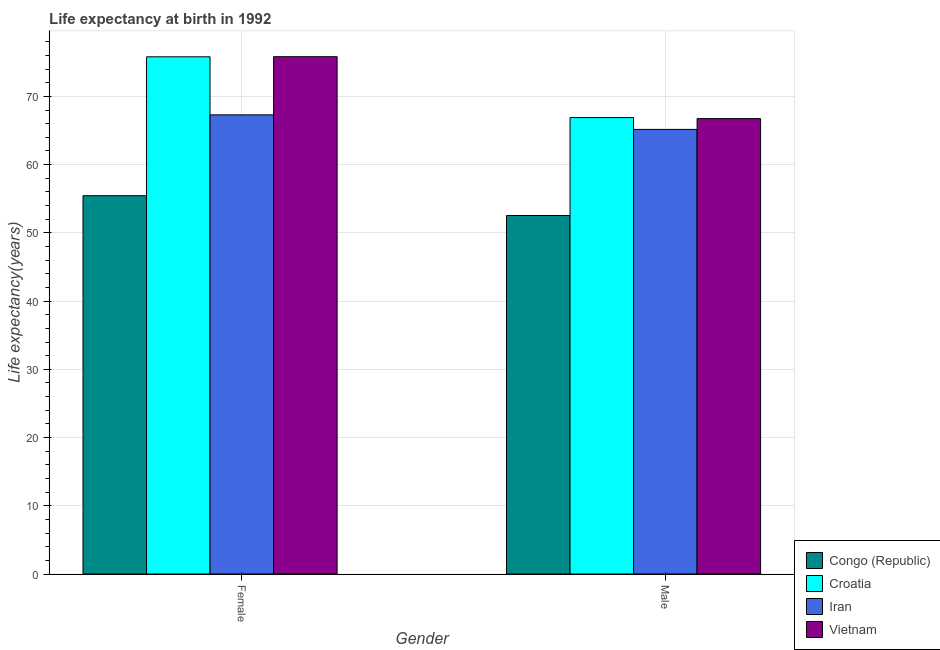How many groups of bars are there?
Make the answer very short. 2. What is the label of the 2nd group of bars from the left?
Make the answer very short. Male. What is the life expectancy(male) in Iran?
Provide a short and direct response. 65.16. Across all countries, what is the maximum life expectancy(male)?
Ensure brevity in your answer.  66.9. Across all countries, what is the minimum life expectancy(female)?
Provide a succinct answer. 55.45. In which country was the life expectancy(male) maximum?
Your response must be concise. Croatia. In which country was the life expectancy(female) minimum?
Your response must be concise. Congo (Republic). What is the total life expectancy(female) in the graph?
Your answer should be very brief. 274.36. What is the difference between the life expectancy(female) in Iran and that in Croatia?
Your response must be concise. -8.5. What is the difference between the life expectancy(male) in Iran and the life expectancy(female) in Croatia?
Your answer should be very brief. -10.64. What is the average life expectancy(female) per country?
Offer a terse response. 68.59. What is the difference between the life expectancy(female) and life expectancy(male) in Congo (Republic)?
Offer a very short reply. 2.9. What is the ratio of the life expectancy(female) in Iran to that in Vietnam?
Provide a succinct answer. 0.89. In how many countries, is the life expectancy(male) greater than the average life expectancy(male) taken over all countries?
Give a very brief answer. 3. What does the 4th bar from the left in Female represents?
Offer a terse response. Vietnam. What does the 1st bar from the right in Female represents?
Offer a terse response. Vietnam. How many countries are there in the graph?
Keep it short and to the point. 4. Does the graph contain grids?
Make the answer very short. Yes. How many legend labels are there?
Your answer should be compact. 4. How are the legend labels stacked?
Your answer should be compact. Vertical. What is the title of the graph?
Ensure brevity in your answer.  Life expectancy at birth in 1992. Does "Macao" appear as one of the legend labels in the graph?
Make the answer very short. No. What is the label or title of the Y-axis?
Your answer should be compact. Life expectancy(years). What is the Life expectancy(years) of Congo (Republic) in Female?
Provide a short and direct response. 55.45. What is the Life expectancy(years) of Croatia in Female?
Ensure brevity in your answer.  75.8. What is the Life expectancy(years) of Iran in Female?
Make the answer very short. 67.3. What is the Life expectancy(years) in Vietnam in Female?
Give a very brief answer. 75.82. What is the Life expectancy(years) of Congo (Republic) in Male?
Your response must be concise. 52.54. What is the Life expectancy(years) of Croatia in Male?
Give a very brief answer. 66.9. What is the Life expectancy(years) in Iran in Male?
Give a very brief answer. 65.16. What is the Life expectancy(years) in Vietnam in Male?
Provide a short and direct response. 66.74. Across all Gender, what is the maximum Life expectancy(years) in Congo (Republic)?
Offer a terse response. 55.45. Across all Gender, what is the maximum Life expectancy(years) in Croatia?
Keep it short and to the point. 75.8. Across all Gender, what is the maximum Life expectancy(years) of Iran?
Your answer should be compact. 67.3. Across all Gender, what is the maximum Life expectancy(years) of Vietnam?
Your response must be concise. 75.82. Across all Gender, what is the minimum Life expectancy(years) of Congo (Republic)?
Your response must be concise. 52.54. Across all Gender, what is the minimum Life expectancy(years) of Croatia?
Provide a succinct answer. 66.9. Across all Gender, what is the minimum Life expectancy(years) in Iran?
Keep it short and to the point. 65.16. Across all Gender, what is the minimum Life expectancy(years) of Vietnam?
Provide a succinct answer. 66.74. What is the total Life expectancy(years) of Congo (Republic) in the graph?
Offer a very short reply. 107.99. What is the total Life expectancy(years) of Croatia in the graph?
Keep it short and to the point. 142.7. What is the total Life expectancy(years) of Iran in the graph?
Offer a terse response. 132.46. What is the total Life expectancy(years) in Vietnam in the graph?
Offer a terse response. 142.56. What is the difference between the Life expectancy(years) in Congo (Republic) in Female and that in Male?
Offer a terse response. 2.9. What is the difference between the Life expectancy(years) of Croatia in Female and that in Male?
Your answer should be very brief. 8.9. What is the difference between the Life expectancy(years) in Iran in Female and that in Male?
Provide a short and direct response. 2.13. What is the difference between the Life expectancy(years) of Vietnam in Female and that in Male?
Your response must be concise. 9.08. What is the difference between the Life expectancy(years) of Congo (Republic) in Female and the Life expectancy(years) of Croatia in Male?
Offer a terse response. -11.46. What is the difference between the Life expectancy(years) of Congo (Republic) in Female and the Life expectancy(years) of Iran in Male?
Make the answer very short. -9.72. What is the difference between the Life expectancy(years) in Congo (Republic) in Female and the Life expectancy(years) in Vietnam in Male?
Your answer should be compact. -11.3. What is the difference between the Life expectancy(years) in Croatia in Female and the Life expectancy(years) in Iran in Male?
Your response must be concise. 10.64. What is the difference between the Life expectancy(years) of Croatia in Female and the Life expectancy(years) of Vietnam in Male?
Your response must be concise. 9.06. What is the difference between the Life expectancy(years) in Iran in Female and the Life expectancy(years) in Vietnam in Male?
Make the answer very short. 0.55. What is the average Life expectancy(years) of Congo (Republic) per Gender?
Provide a succinct answer. 53.99. What is the average Life expectancy(years) in Croatia per Gender?
Ensure brevity in your answer.  71.35. What is the average Life expectancy(years) of Iran per Gender?
Your answer should be compact. 66.23. What is the average Life expectancy(years) in Vietnam per Gender?
Your answer should be compact. 71.28. What is the difference between the Life expectancy(years) of Congo (Republic) and Life expectancy(years) of Croatia in Female?
Provide a succinct answer. -20.36. What is the difference between the Life expectancy(years) of Congo (Republic) and Life expectancy(years) of Iran in Female?
Keep it short and to the point. -11.85. What is the difference between the Life expectancy(years) of Congo (Republic) and Life expectancy(years) of Vietnam in Female?
Your answer should be very brief. -20.38. What is the difference between the Life expectancy(years) of Croatia and Life expectancy(years) of Iran in Female?
Make the answer very short. 8.51. What is the difference between the Life expectancy(years) in Croatia and Life expectancy(years) in Vietnam in Female?
Keep it short and to the point. -0.02. What is the difference between the Life expectancy(years) of Iran and Life expectancy(years) of Vietnam in Female?
Your answer should be compact. -8.53. What is the difference between the Life expectancy(years) in Congo (Republic) and Life expectancy(years) in Croatia in Male?
Keep it short and to the point. -14.36. What is the difference between the Life expectancy(years) in Congo (Republic) and Life expectancy(years) in Iran in Male?
Ensure brevity in your answer.  -12.62. What is the difference between the Life expectancy(years) of Congo (Republic) and Life expectancy(years) of Vietnam in Male?
Offer a terse response. -14.2. What is the difference between the Life expectancy(years) in Croatia and Life expectancy(years) in Iran in Male?
Your answer should be compact. 1.74. What is the difference between the Life expectancy(years) in Croatia and Life expectancy(years) in Vietnam in Male?
Offer a very short reply. 0.16. What is the difference between the Life expectancy(years) of Iran and Life expectancy(years) of Vietnam in Male?
Offer a terse response. -1.58. What is the ratio of the Life expectancy(years) in Congo (Republic) in Female to that in Male?
Your answer should be compact. 1.06. What is the ratio of the Life expectancy(years) of Croatia in Female to that in Male?
Ensure brevity in your answer.  1.13. What is the ratio of the Life expectancy(years) in Iran in Female to that in Male?
Offer a terse response. 1.03. What is the ratio of the Life expectancy(years) of Vietnam in Female to that in Male?
Make the answer very short. 1.14. What is the difference between the highest and the second highest Life expectancy(years) of Congo (Republic)?
Provide a short and direct response. 2.9. What is the difference between the highest and the second highest Life expectancy(years) in Iran?
Give a very brief answer. 2.13. What is the difference between the highest and the second highest Life expectancy(years) of Vietnam?
Give a very brief answer. 9.08. What is the difference between the highest and the lowest Life expectancy(years) of Congo (Republic)?
Offer a terse response. 2.9. What is the difference between the highest and the lowest Life expectancy(years) of Croatia?
Provide a succinct answer. 8.9. What is the difference between the highest and the lowest Life expectancy(years) in Iran?
Ensure brevity in your answer.  2.13. What is the difference between the highest and the lowest Life expectancy(years) in Vietnam?
Ensure brevity in your answer.  9.08. 